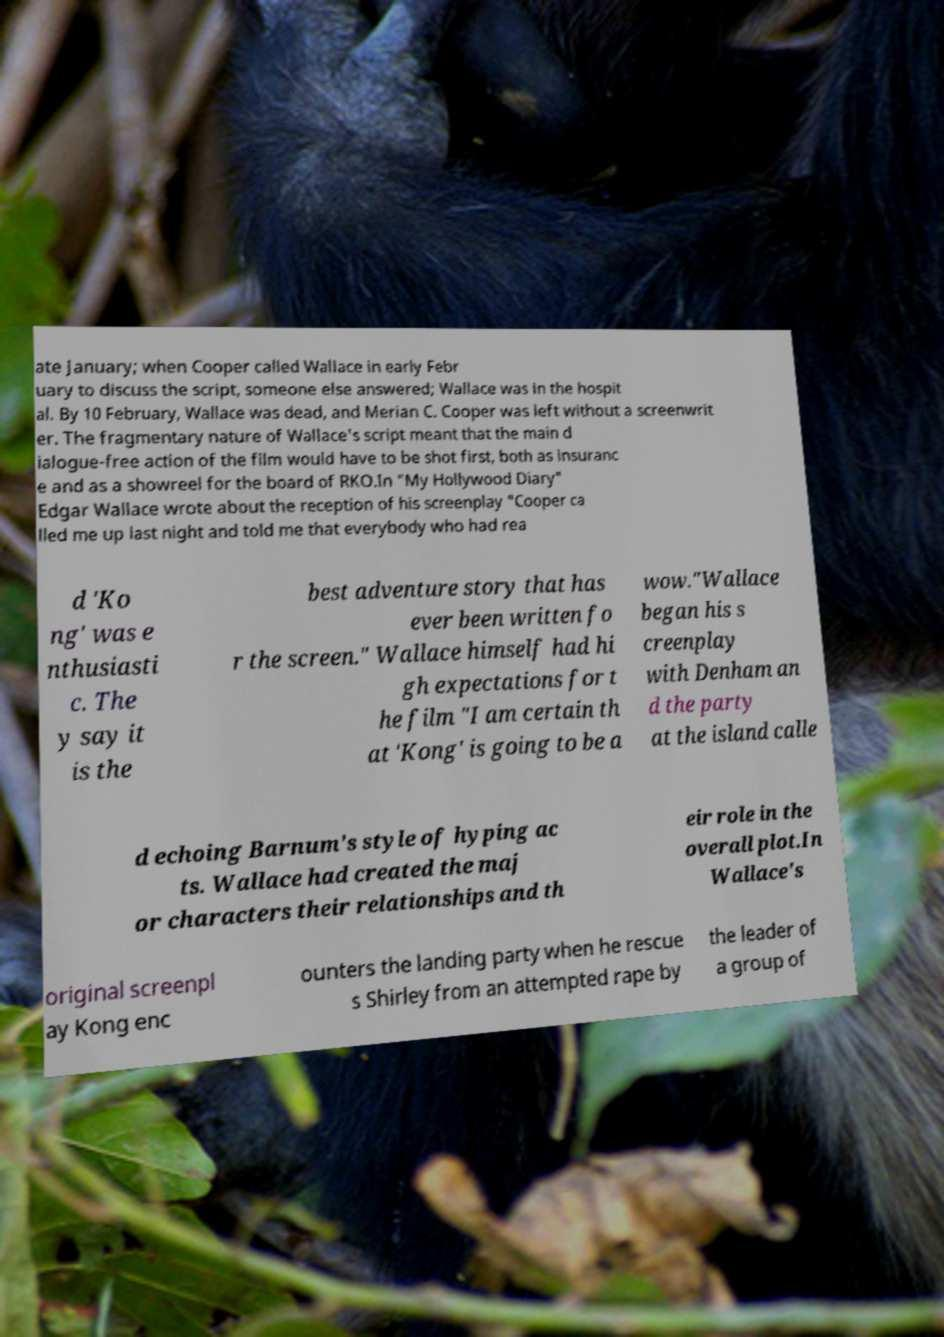Please read and relay the text visible in this image. What does it say? ate January; when Cooper called Wallace in early Febr uary to discuss the script, someone else answered; Wallace was in the hospit al. By 10 February, Wallace was dead, and Merian C. Cooper was left without a screenwrit er. The fragmentary nature of Wallace's script meant that the main d ialogue-free action of the film would have to be shot first, both as insuranc e and as a showreel for the board of RKO.In "My Hollywood Diary" Edgar Wallace wrote about the reception of his screenplay "Cooper ca lled me up last night and told me that everybody who had rea d 'Ko ng' was e nthusiasti c. The y say it is the best adventure story that has ever been written fo r the screen." Wallace himself had hi gh expectations for t he film "I am certain th at 'Kong' is going to be a wow."Wallace began his s creenplay with Denham an d the party at the island calle d echoing Barnum's style of hyping ac ts. Wallace had created the maj or characters their relationships and th eir role in the overall plot.In Wallace's original screenpl ay Kong enc ounters the landing party when he rescue s Shirley from an attempted rape by the leader of a group of 